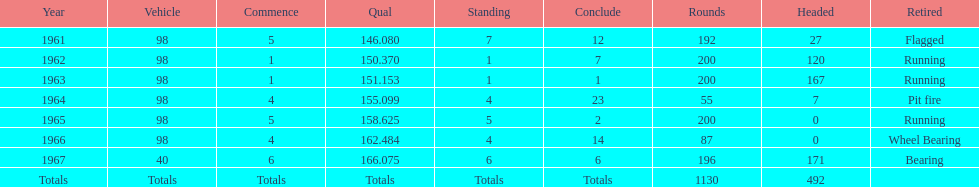In how many indy 500 races, has jones been flagged? 1. 